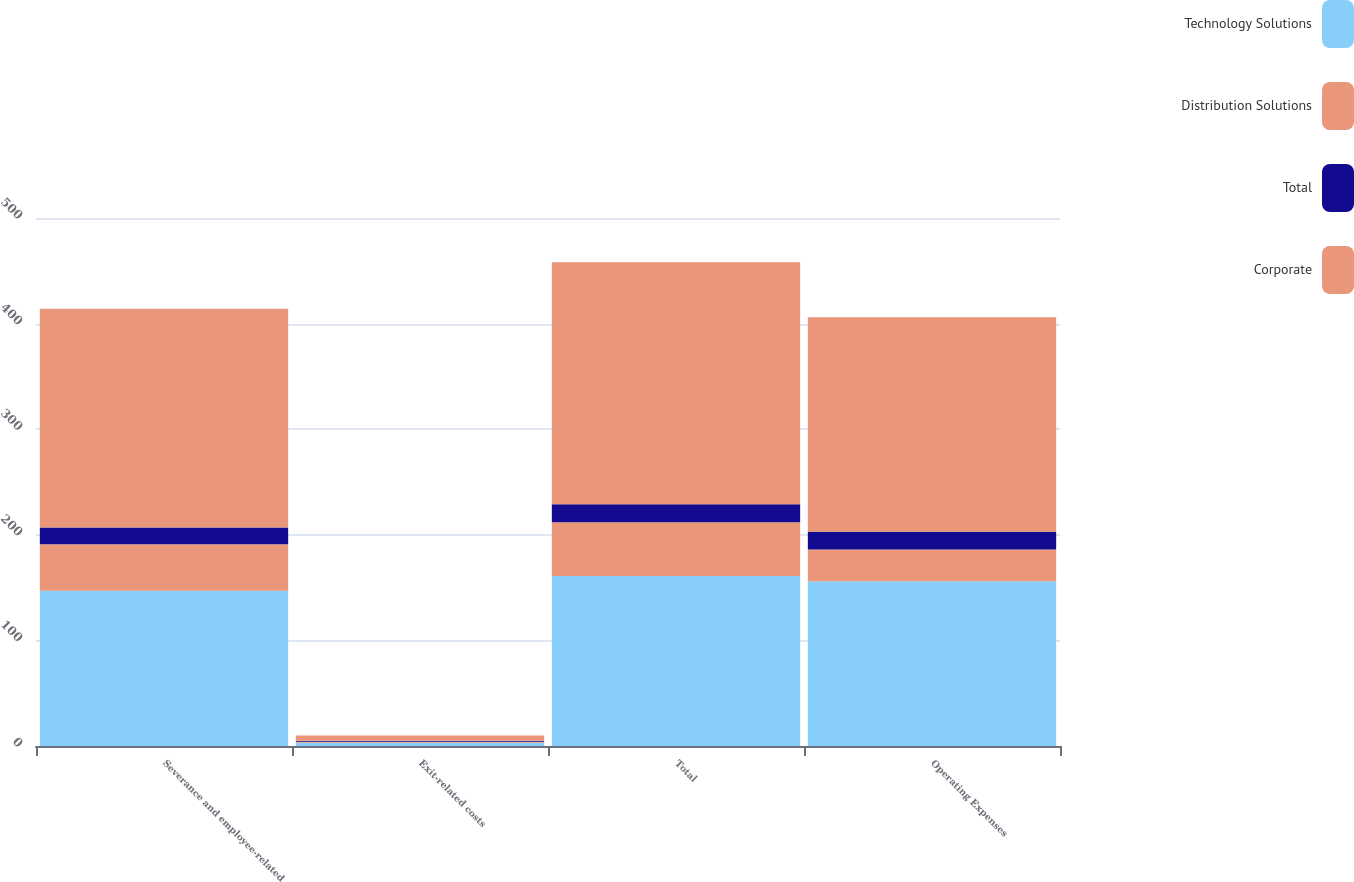<chart> <loc_0><loc_0><loc_500><loc_500><stacked_bar_chart><ecel><fcel>Severance and employee-related<fcel>Exit-related costs<fcel>Total<fcel>Operating Expenses<nl><fcel>Technology Solutions<fcel>147<fcel>3<fcel>161<fcel>156<nl><fcel>Distribution Solutions<fcel>44<fcel>1<fcel>51<fcel>30<nl><fcel>Total<fcel>16<fcel>1<fcel>17<fcel>17<nl><fcel>Corporate<fcel>207<fcel>5<fcel>229<fcel>203<nl></chart> 